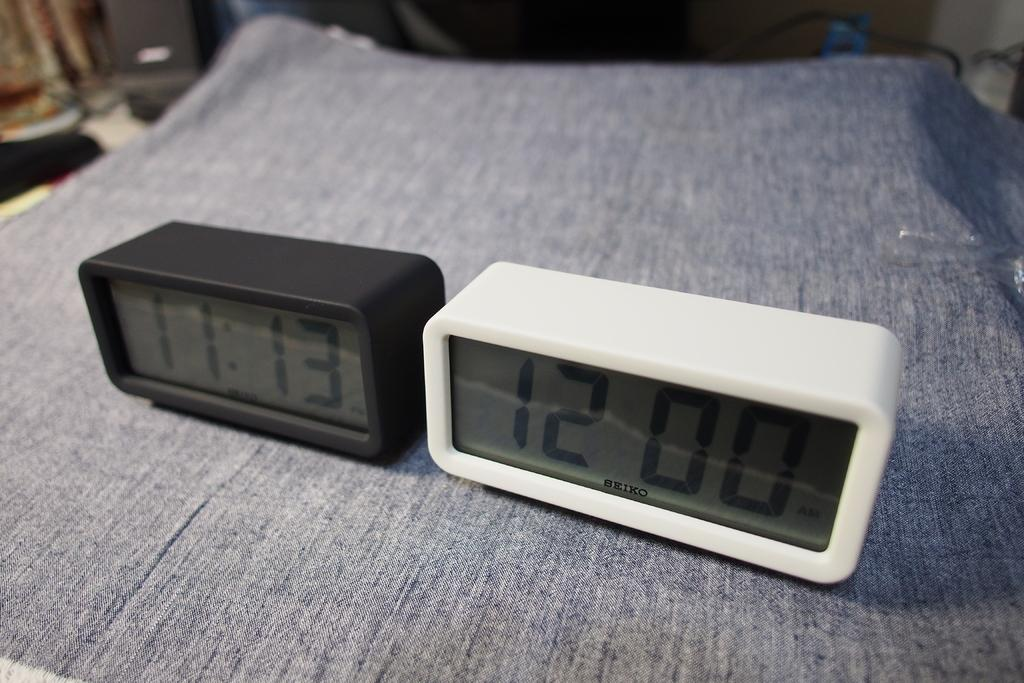<image>
Share a concise interpretation of the image provided. a black and white set of digital clocks by SEIKO on a grey surface 